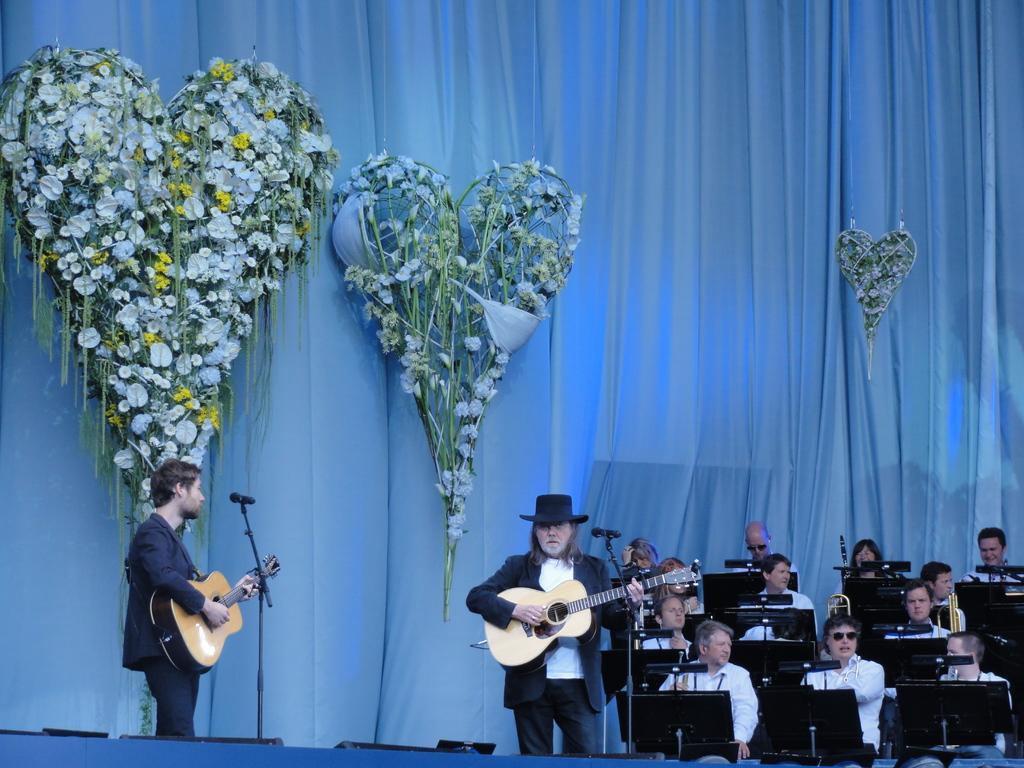In one or two sentences, can you explain what this image depicts? In the image we can see there are people who are sitting on chair and there are two men who are standing and holding guitar in their hand. 